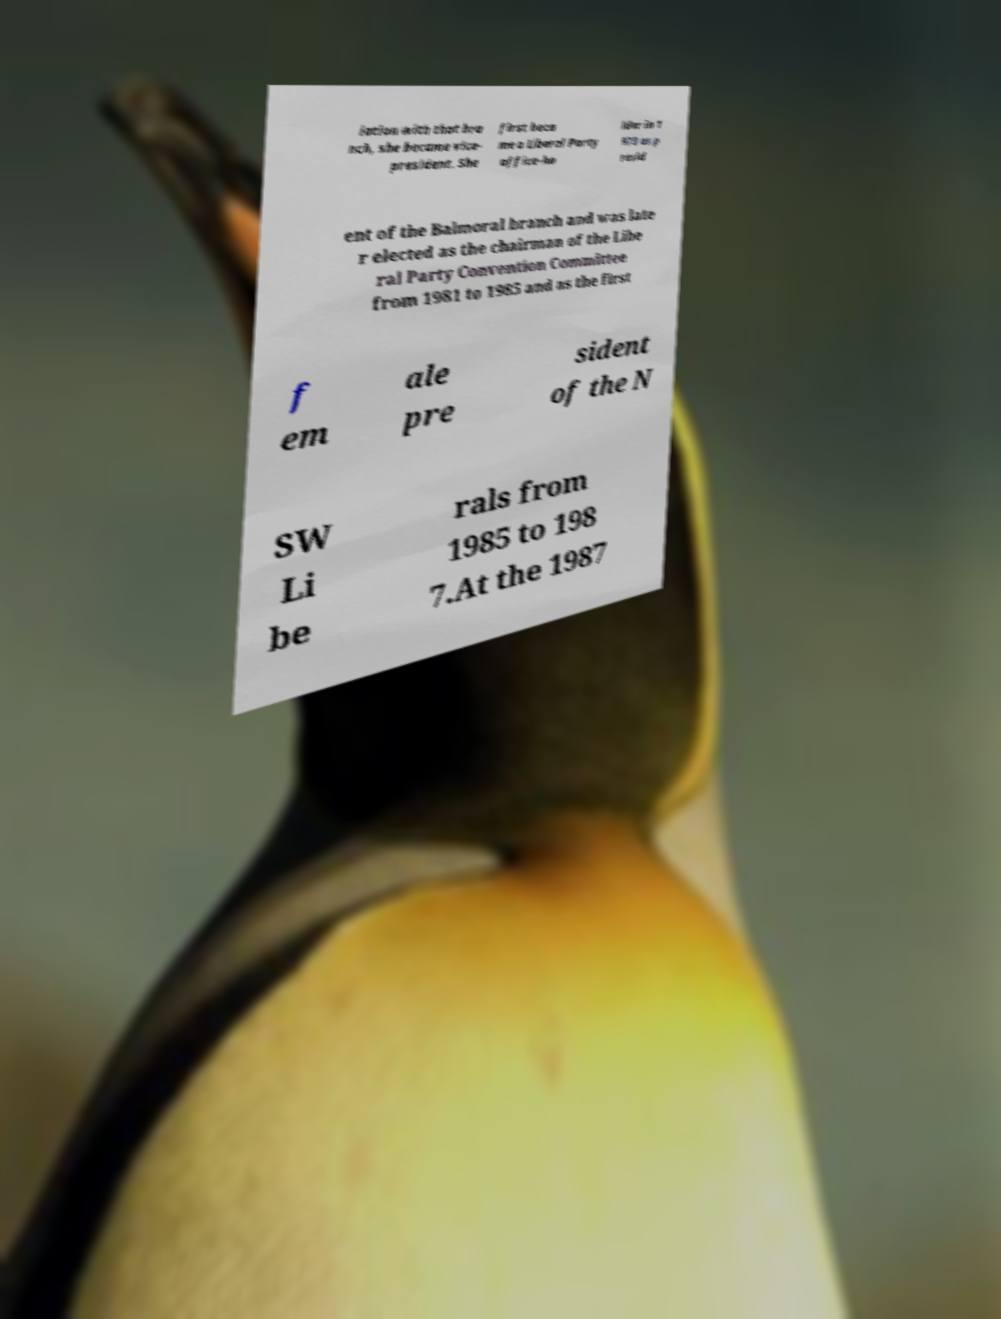Can you accurately transcribe the text from the provided image for me? iation with that bra nch, she became vice- president. She first beca me a Liberal Party office-ho lder in 1 973 as p resid ent of the Balmoral branch and was late r elected as the chairman of the Libe ral Party Convention Committee from 1981 to 1985 and as the first f em ale pre sident of the N SW Li be rals from 1985 to 198 7.At the 1987 